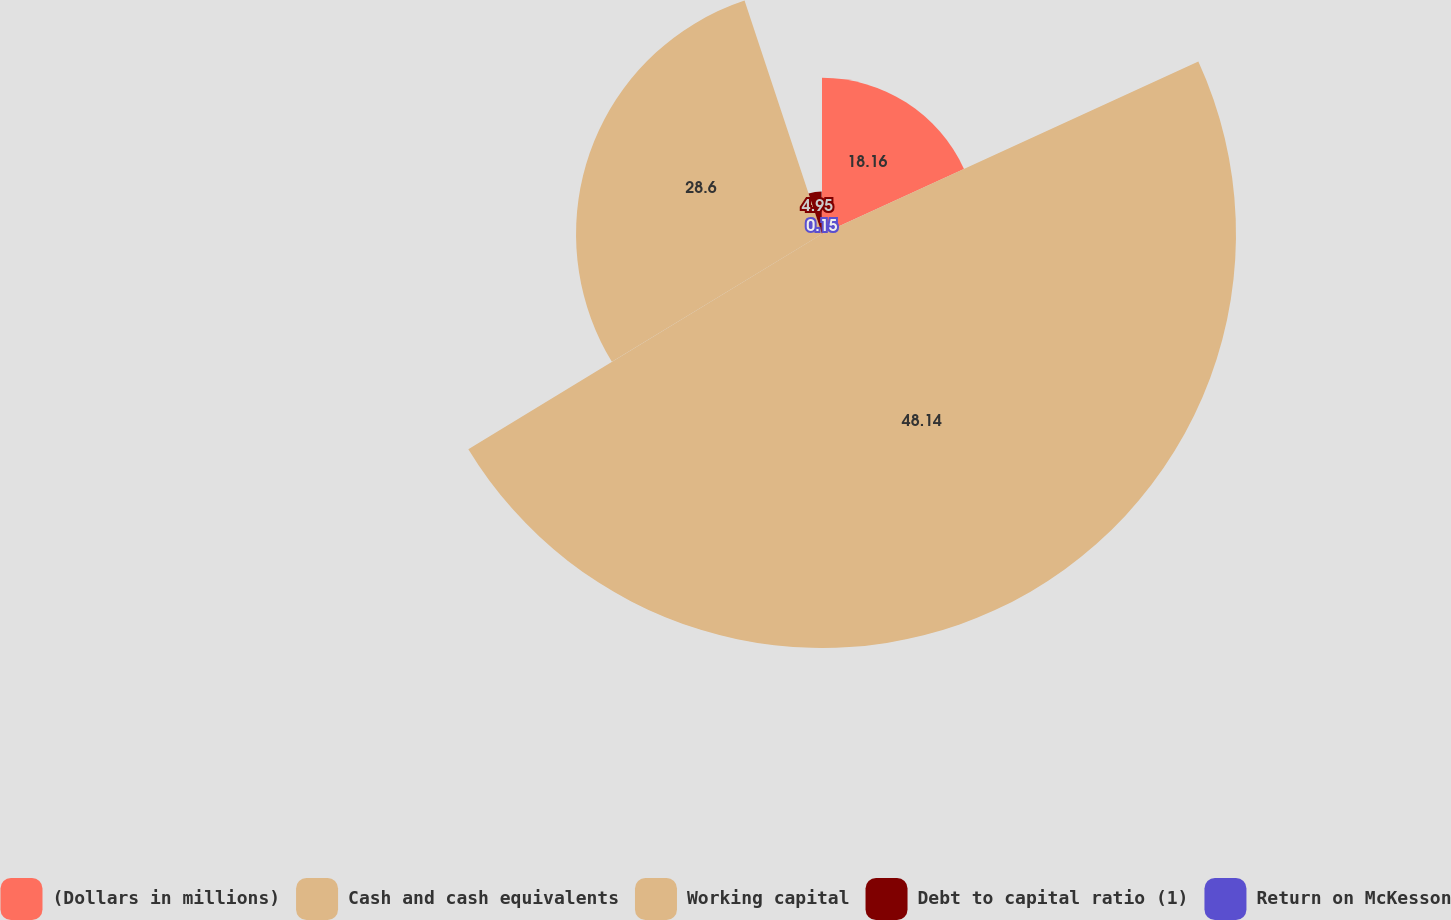Convert chart. <chart><loc_0><loc_0><loc_500><loc_500><pie_chart><fcel>(Dollars in millions)<fcel>Cash and cash equivalents<fcel>Working capital<fcel>Debt to capital ratio (1)<fcel>Return on McKesson<nl><fcel>18.16%<fcel>48.14%<fcel>28.6%<fcel>4.95%<fcel>0.15%<nl></chart> 